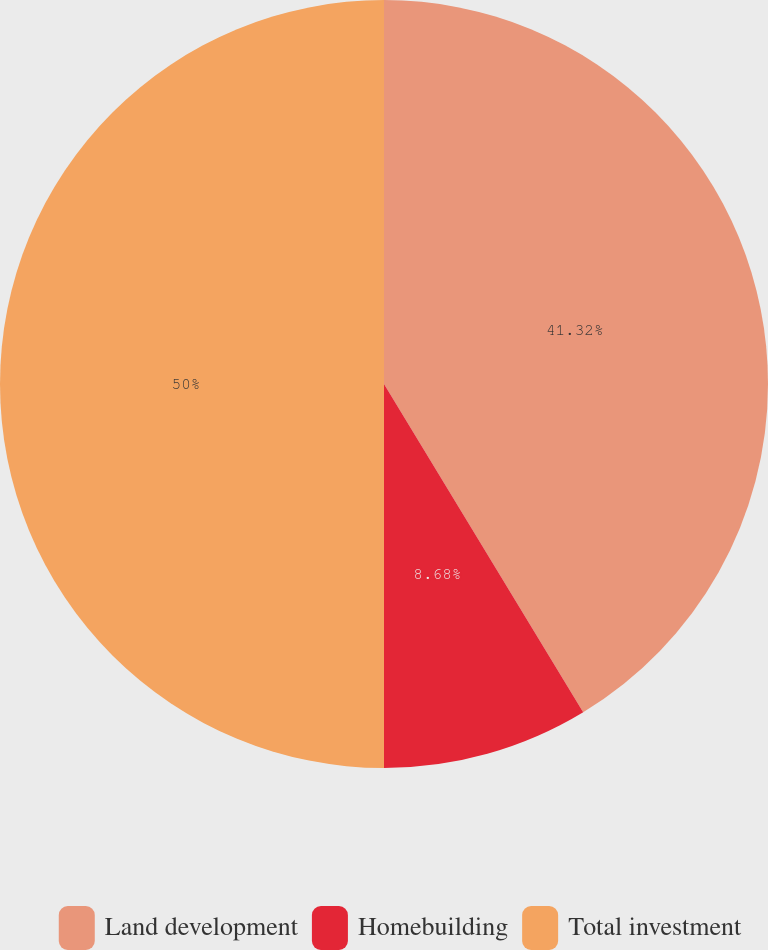<chart> <loc_0><loc_0><loc_500><loc_500><pie_chart><fcel>Land development<fcel>Homebuilding<fcel>Total investment<nl><fcel>41.32%<fcel>8.68%<fcel>50.0%<nl></chart> 